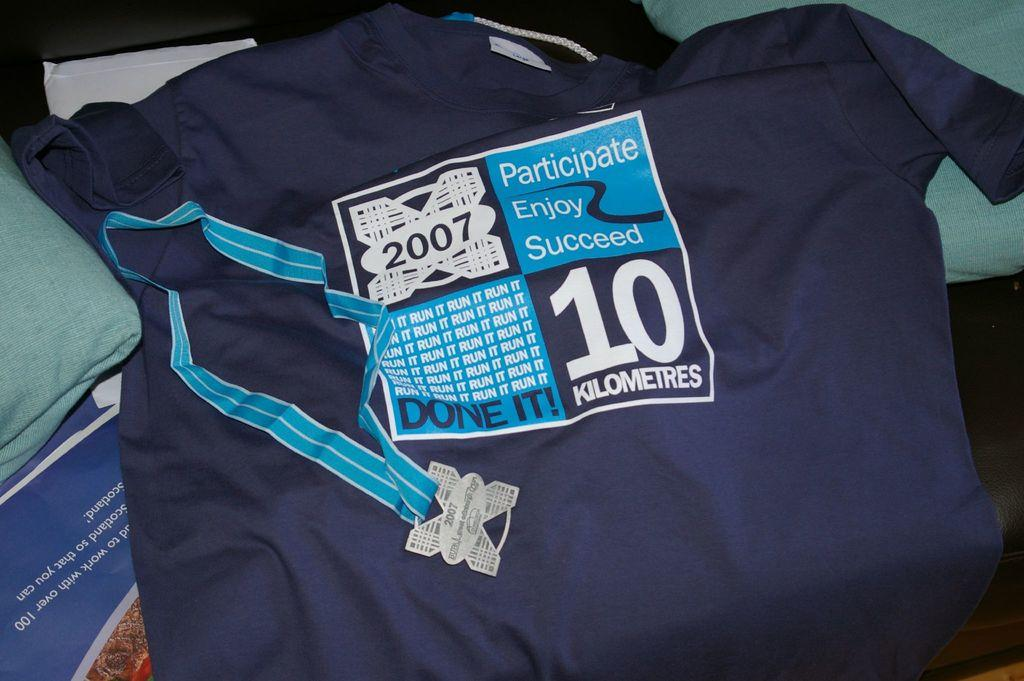<image>
Present a compact description of the photo's key features. Sports jersey with a square in the middle that has Participate Enjoy Succeed in white lettering. 